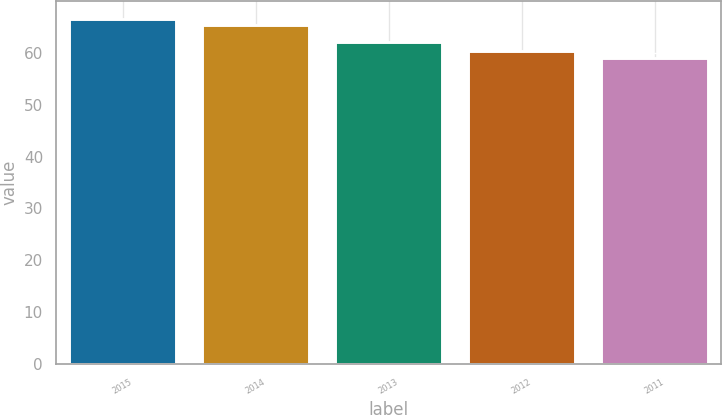Convert chart. <chart><loc_0><loc_0><loc_500><loc_500><bar_chart><fcel>2015<fcel>2014<fcel>2013<fcel>2012<fcel>2011<nl><fcel>66.62<fcel>65.34<fcel>62.2<fcel>60.45<fcel>58.96<nl></chart> 